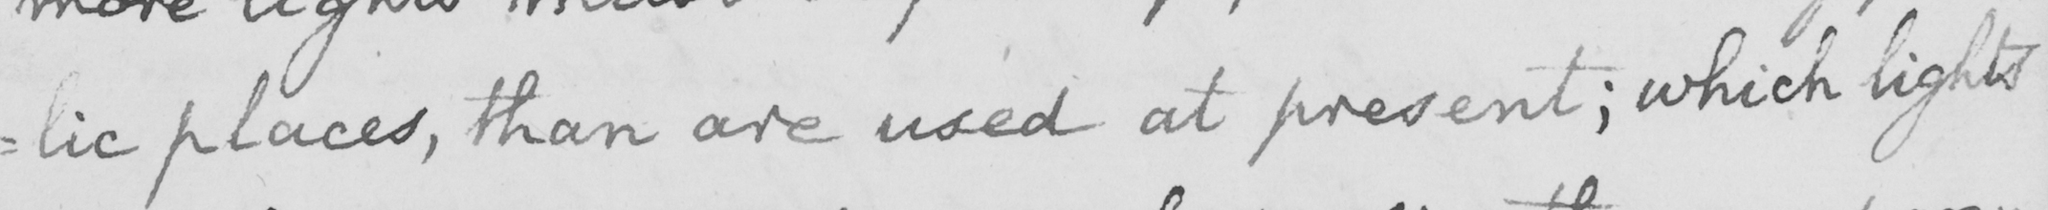What is written in this line of handwriting? : lic places , than are used at present ; which lights 